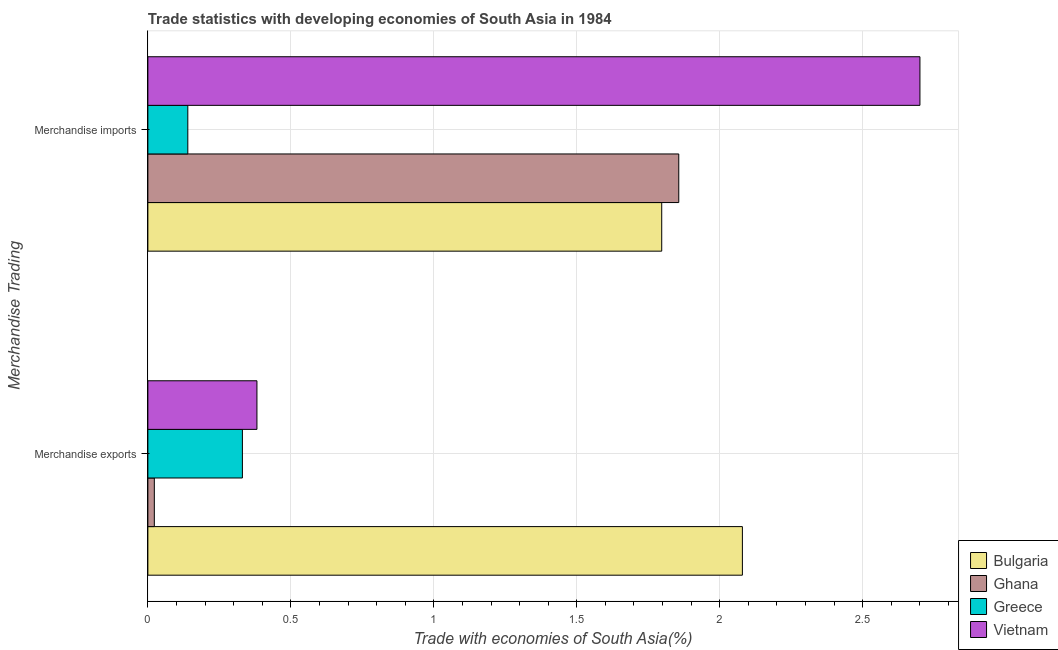How many different coloured bars are there?
Make the answer very short. 4. How many groups of bars are there?
Your response must be concise. 2. How many bars are there on the 2nd tick from the top?
Provide a succinct answer. 4. How many bars are there on the 2nd tick from the bottom?
Ensure brevity in your answer.  4. What is the merchandise exports in Bulgaria?
Your answer should be compact. 2.08. Across all countries, what is the maximum merchandise imports?
Keep it short and to the point. 2.7. Across all countries, what is the minimum merchandise exports?
Make the answer very short. 0.02. What is the total merchandise imports in the graph?
Offer a very short reply. 6.49. What is the difference between the merchandise imports in Bulgaria and that in Vietnam?
Your response must be concise. -0.9. What is the difference between the merchandise exports in Greece and the merchandise imports in Bulgaria?
Your answer should be very brief. -1.47. What is the average merchandise imports per country?
Offer a terse response. 1.62. What is the difference between the merchandise exports and merchandise imports in Vietnam?
Provide a succinct answer. -2.32. In how many countries, is the merchandise exports greater than 0.7 %?
Your response must be concise. 1. What is the ratio of the merchandise imports in Greece to that in Ghana?
Offer a very short reply. 0.08. What does the 2nd bar from the top in Merchandise exports represents?
Offer a very short reply. Greece. How many countries are there in the graph?
Your answer should be compact. 4. What is the difference between two consecutive major ticks on the X-axis?
Your response must be concise. 0.5. Are the values on the major ticks of X-axis written in scientific E-notation?
Your response must be concise. No. Does the graph contain grids?
Offer a terse response. Yes. Where does the legend appear in the graph?
Offer a terse response. Bottom right. How are the legend labels stacked?
Your answer should be very brief. Vertical. What is the title of the graph?
Your answer should be very brief. Trade statistics with developing economies of South Asia in 1984. What is the label or title of the X-axis?
Your answer should be compact. Trade with economies of South Asia(%). What is the label or title of the Y-axis?
Keep it short and to the point. Merchandise Trading. What is the Trade with economies of South Asia(%) in Bulgaria in Merchandise exports?
Provide a succinct answer. 2.08. What is the Trade with economies of South Asia(%) in Ghana in Merchandise exports?
Provide a short and direct response. 0.02. What is the Trade with economies of South Asia(%) in Greece in Merchandise exports?
Your answer should be very brief. 0.33. What is the Trade with economies of South Asia(%) of Vietnam in Merchandise exports?
Your response must be concise. 0.38. What is the Trade with economies of South Asia(%) of Bulgaria in Merchandise imports?
Ensure brevity in your answer.  1.8. What is the Trade with economies of South Asia(%) in Ghana in Merchandise imports?
Your answer should be very brief. 1.86. What is the Trade with economies of South Asia(%) in Greece in Merchandise imports?
Keep it short and to the point. 0.14. What is the Trade with economies of South Asia(%) in Vietnam in Merchandise imports?
Offer a terse response. 2.7. Across all Merchandise Trading, what is the maximum Trade with economies of South Asia(%) of Bulgaria?
Provide a short and direct response. 2.08. Across all Merchandise Trading, what is the maximum Trade with economies of South Asia(%) of Ghana?
Your response must be concise. 1.86. Across all Merchandise Trading, what is the maximum Trade with economies of South Asia(%) in Greece?
Your answer should be very brief. 0.33. Across all Merchandise Trading, what is the maximum Trade with economies of South Asia(%) of Vietnam?
Provide a short and direct response. 2.7. Across all Merchandise Trading, what is the minimum Trade with economies of South Asia(%) of Bulgaria?
Give a very brief answer. 1.8. Across all Merchandise Trading, what is the minimum Trade with economies of South Asia(%) of Ghana?
Make the answer very short. 0.02. Across all Merchandise Trading, what is the minimum Trade with economies of South Asia(%) in Greece?
Give a very brief answer. 0.14. Across all Merchandise Trading, what is the minimum Trade with economies of South Asia(%) of Vietnam?
Provide a short and direct response. 0.38. What is the total Trade with economies of South Asia(%) of Bulgaria in the graph?
Give a very brief answer. 3.88. What is the total Trade with economies of South Asia(%) of Ghana in the graph?
Make the answer very short. 1.88. What is the total Trade with economies of South Asia(%) in Greece in the graph?
Make the answer very short. 0.47. What is the total Trade with economies of South Asia(%) in Vietnam in the graph?
Offer a terse response. 3.08. What is the difference between the Trade with economies of South Asia(%) in Bulgaria in Merchandise exports and that in Merchandise imports?
Make the answer very short. 0.28. What is the difference between the Trade with economies of South Asia(%) in Ghana in Merchandise exports and that in Merchandise imports?
Your response must be concise. -1.83. What is the difference between the Trade with economies of South Asia(%) of Greece in Merchandise exports and that in Merchandise imports?
Offer a very short reply. 0.19. What is the difference between the Trade with economies of South Asia(%) in Vietnam in Merchandise exports and that in Merchandise imports?
Your answer should be compact. -2.32. What is the difference between the Trade with economies of South Asia(%) of Bulgaria in Merchandise exports and the Trade with economies of South Asia(%) of Ghana in Merchandise imports?
Offer a very short reply. 0.22. What is the difference between the Trade with economies of South Asia(%) of Bulgaria in Merchandise exports and the Trade with economies of South Asia(%) of Greece in Merchandise imports?
Provide a short and direct response. 1.94. What is the difference between the Trade with economies of South Asia(%) in Bulgaria in Merchandise exports and the Trade with economies of South Asia(%) in Vietnam in Merchandise imports?
Keep it short and to the point. -0.62. What is the difference between the Trade with economies of South Asia(%) in Ghana in Merchandise exports and the Trade with economies of South Asia(%) in Greece in Merchandise imports?
Your answer should be very brief. -0.12. What is the difference between the Trade with economies of South Asia(%) in Ghana in Merchandise exports and the Trade with economies of South Asia(%) in Vietnam in Merchandise imports?
Make the answer very short. -2.68. What is the difference between the Trade with economies of South Asia(%) of Greece in Merchandise exports and the Trade with economies of South Asia(%) of Vietnam in Merchandise imports?
Offer a terse response. -2.37. What is the average Trade with economies of South Asia(%) of Bulgaria per Merchandise Trading?
Your answer should be compact. 1.94. What is the average Trade with economies of South Asia(%) in Ghana per Merchandise Trading?
Provide a short and direct response. 0.94. What is the average Trade with economies of South Asia(%) in Greece per Merchandise Trading?
Your answer should be compact. 0.24. What is the average Trade with economies of South Asia(%) in Vietnam per Merchandise Trading?
Provide a short and direct response. 1.54. What is the difference between the Trade with economies of South Asia(%) in Bulgaria and Trade with economies of South Asia(%) in Ghana in Merchandise exports?
Your answer should be very brief. 2.06. What is the difference between the Trade with economies of South Asia(%) of Bulgaria and Trade with economies of South Asia(%) of Greece in Merchandise exports?
Ensure brevity in your answer.  1.75. What is the difference between the Trade with economies of South Asia(%) in Bulgaria and Trade with economies of South Asia(%) in Vietnam in Merchandise exports?
Provide a succinct answer. 1.7. What is the difference between the Trade with economies of South Asia(%) of Ghana and Trade with economies of South Asia(%) of Greece in Merchandise exports?
Offer a terse response. -0.31. What is the difference between the Trade with economies of South Asia(%) in Ghana and Trade with economies of South Asia(%) in Vietnam in Merchandise exports?
Ensure brevity in your answer.  -0.36. What is the difference between the Trade with economies of South Asia(%) in Greece and Trade with economies of South Asia(%) in Vietnam in Merchandise exports?
Ensure brevity in your answer.  -0.05. What is the difference between the Trade with economies of South Asia(%) of Bulgaria and Trade with economies of South Asia(%) of Ghana in Merchandise imports?
Your answer should be compact. -0.06. What is the difference between the Trade with economies of South Asia(%) in Bulgaria and Trade with economies of South Asia(%) in Greece in Merchandise imports?
Provide a succinct answer. 1.66. What is the difference between the Trade with economies of South Asia(%) in Bulgaria and Trade with economies of South Asia(%) in Vietnam in Merchandise imports?
Keep it short and to the point. -0.9. What is the difference between the Trade with economies of South Asia(%) in Ghana and Trade with economies of South Asia(%) in Greece in Merchandise imports?
Provide a succinct answer. 1.72. What is the difference between the Trade with economies of South Asia(%) in Ghana and Trade with economies of South Asia(%) in Vietnam in Merchandise imports?
Provide a short and direct response. -0.84. What is the difference between the Trade with economies of South Asia(%) in Greece and Trade with economies of South Asia(%) in Vietnam in Merchandise imports?
Your response must be concise. -2.56. What is the ratio of the Trade with economies of South Asia(%) in Bulgaria in Merchandise exports to that in Merchandise imports?
Your response must be concise. 1.16. What is the ratio of the Trade with economies of South Asia(%) of Ghana in Merchandise exports to that in Merchandise imports?
Your response must be concise. 0.01. What is the ratio of the Trade with economies of South Asia(%) in Greece in Merchandise exports to that in Merchandise imports?
Your answer should be very brief. 2.37. What is the ratio of the Trade with economies of South Asia(%) in Vietnam in Merchandise exports to that in Merchandise imports?
Your response must be concise. 0.14. What is the difference between the highest and the second highest Trade with economies of South Asia(%) of Bulgaria?
Offer a terse response. 0.28. What is the difference between the highest and the second highest Trade with economies of South Asia(%) in Ghana?
Provide a succinct answer. 1.83. What is the difference between the highest and the second highest Trade with economies of South Asia(%) in Greece?
Provide a short and direct response. 0.19. What is the difference between the highest and the second highest Trade with economies of South Asia(%) in Vietnam?
Your answer should be compact. 2.32. What is the difference between the highest and the lowest Trade with economies of South Asia(%) of Bulgaria?
Make the answer very short. 0.28. What is the difference between the highest and the lowest Trade with economies of South Asia(%) in Ghana?
Your answer should be very brief. 1.83. What is the difference between the highest and the lowest Trade with economies of South Asia(%) in Greece?
Offer a very short reply. 0.19. What is the difference between the highest and the lowest Trade with economies of South Asia(%) of Vietnam?
Offer a terse response. 2.32. 